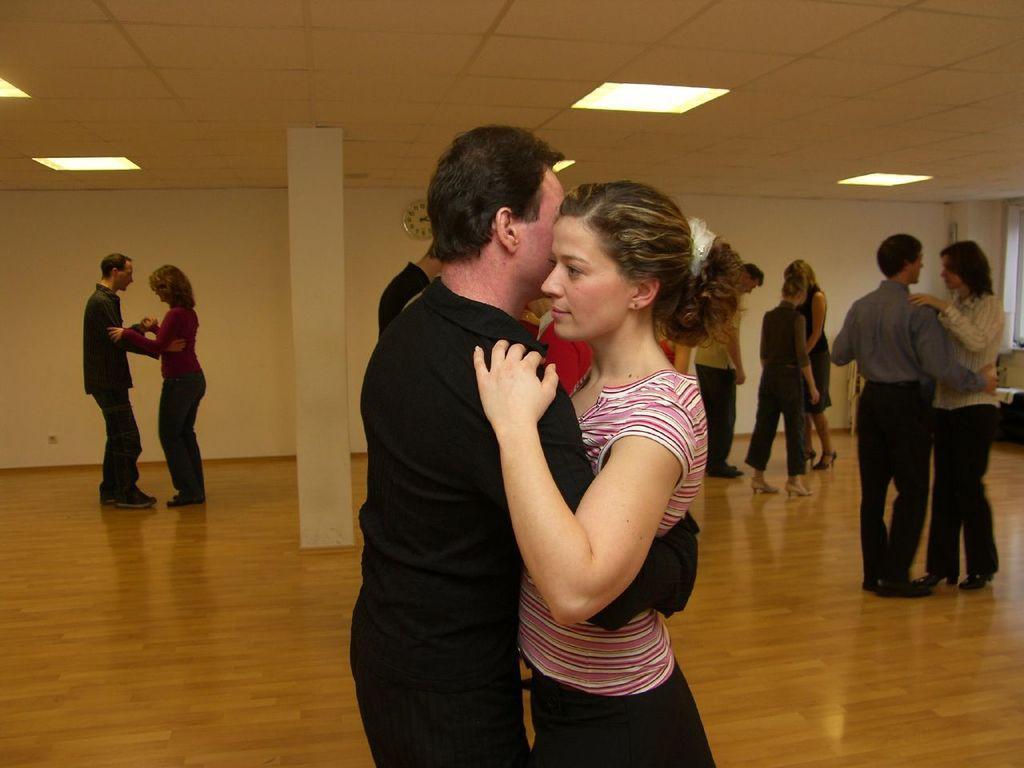Can you describe this image briefly? In the center of the image we can see couple standing on the floor. In the background we can see many persons, pillar, wall and lights. 